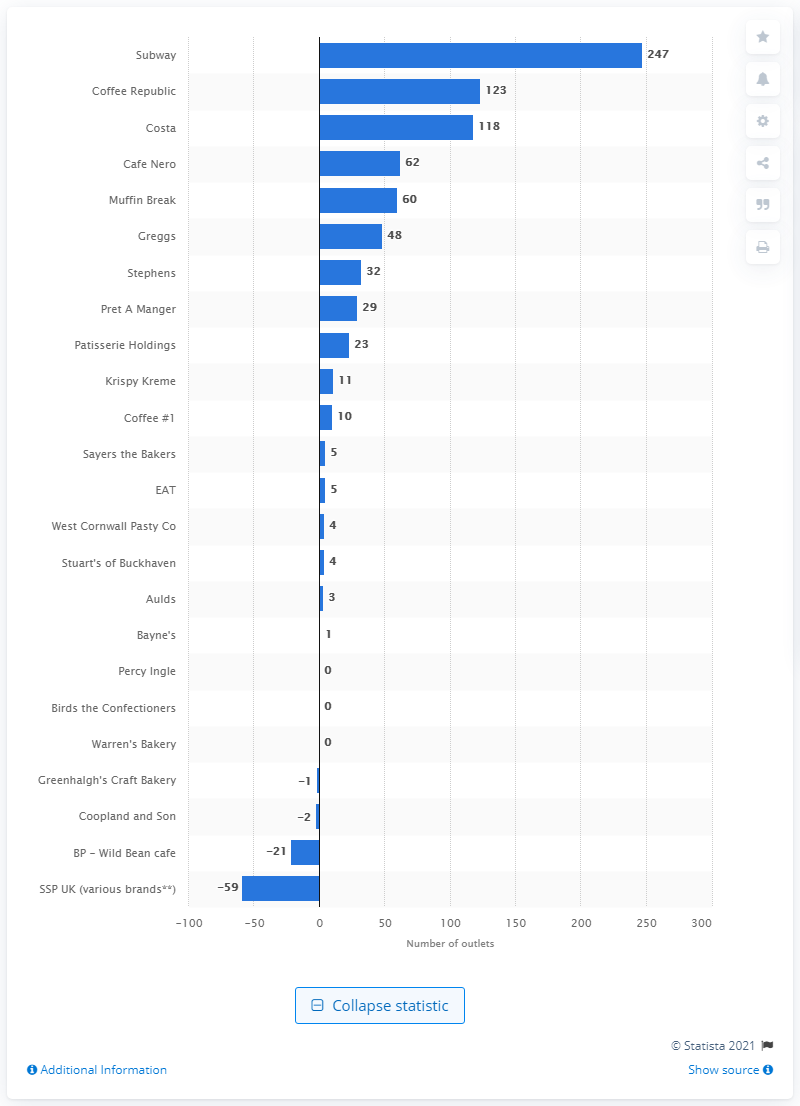Highlight a few significant elements in this photo. In 2016, Subway opened 247 new stores in the UK. 